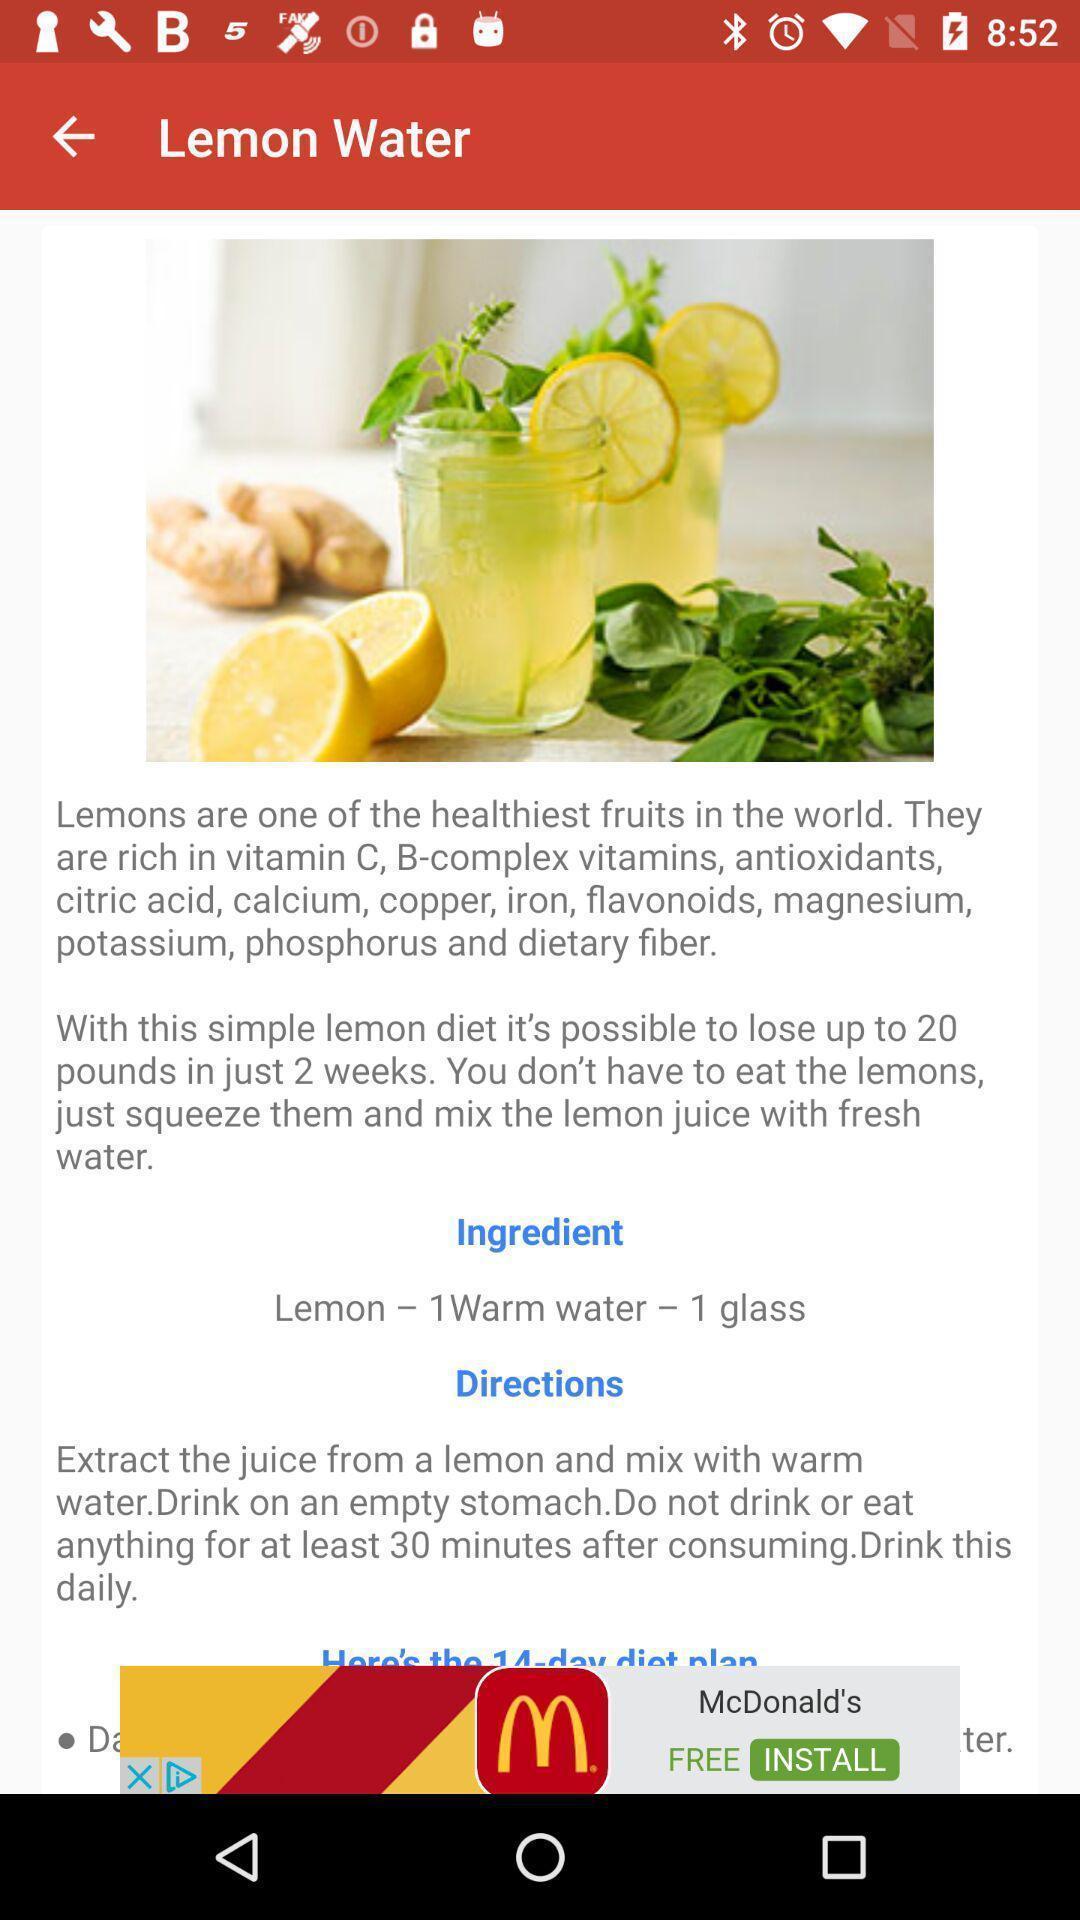Provide a description of this screenshot. Page that displaying describing of vitamin c. 